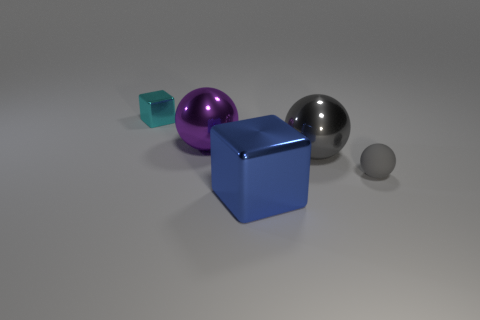There is a small thing that is on the left side of the large blue thing; does it have the same color as the large object that is right of the large blue shiny object?
Provide a short and direct response. No. What shape is the thing that is the same color as the tiny ball?
Provide a short and direct response. Sphere. What number of matte things are either large objects or small gray cylinders?
Ensure brevity in your answer.  0. There is a shiny cube that is behind the ball that is right of the gray thing behind the rubber object; what color is it?
Ensure brevity in your answer.  Cyan. What color is the small rubber thing that is the same shape as the gray metal object?
Ensure brevity in your answer.  Gray. Is there anything else of the same color as the small metal object?
Offer a terse response. No. How many other things are made of the same material as the large gray ball?
Keep it short and to the point. 3. What size is the purple metal thing?
Keep it short and to the point. Large. Is there another tiny rubber thing of the same shape as the gray matte thing?
Offer a very short reply. No. How many objects are either purple shiny balls or shiny blocks behind the gray metallic ball?
Keep it short and to the point. 2. 